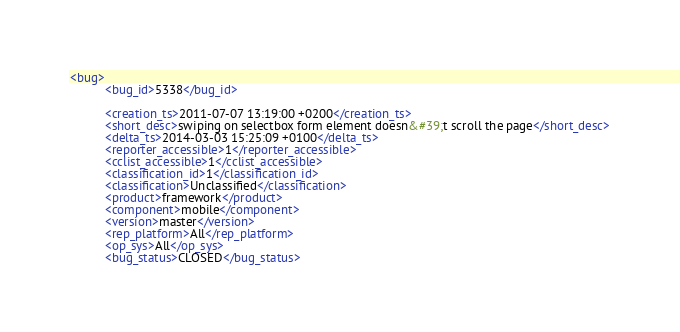<code> <loc_0><loc_0><loc_500><loc_500><_XML_><bug>
          <bug_id>5338</bug_id>
          
          <creation_ts>2011-07-07 13:19:00 +0200</creation_ts>
          <short_desc>swiping on selectbox form element doesn&#39;t scroll the page</short_desc>
          <delta_ts>2014-03-03 15:25:09 +0100</delta_ts>
          <reporter_accessible>1</reporter_accessible>
          <cclist_accessible>1</cclist_accessible>
          <classification_id>1</classification_id>
          <classification>Unclassified</classification>
          <product>framework</product>
          <component>mobile</component>
          <version>master</version>
          <rep_platform>All</rep_platform>
          <op_sys>All</op_sys>
          <bug_status>CLOSED</bug_status></code> 